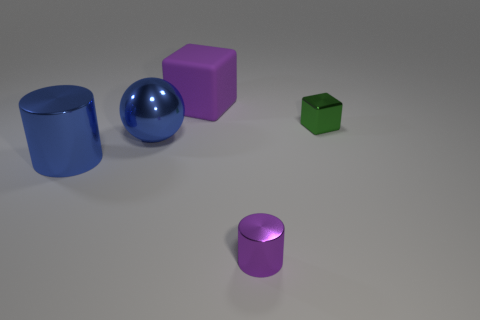There is a big block that is the same color as the small cylinder; what is it made of?
Make the answer very short. Rubber. There is a cube to the right of the purple matte object; does it have the same color as the shiny cylinder on the left side of the large purple matte object?
Make the answer very short. No. Is there a yellow object that has the same material as the small purple cylinder?
Offer a terse response. No. How big is the cube to the right of the purple thing in front of the blue metal cylinder?
Provide a short and direct response. Small. Is the number of red metallic cylinders greater than the number of purple rubber things?
Your response must be concise. No. Do the rubber object that is behind the blue shiny cylinder and the blue sphere have the same size?
Offer a very short reply. Yes. How many tiny shiny things are the same color as the big cylinder?
Give a very brief answer. 0. Is the shape of the tiny green object the same as the matte object?
Provide a short and direct response. Yes. The other object that is the same shape as the large purple rubber object is what size?
Offer a very short reply. Small. Is the number of things behind the tiny purple cylinder greater than the number of purple shiny cylinders that are behind the matte thing?
Make the answer very short. Yes. 